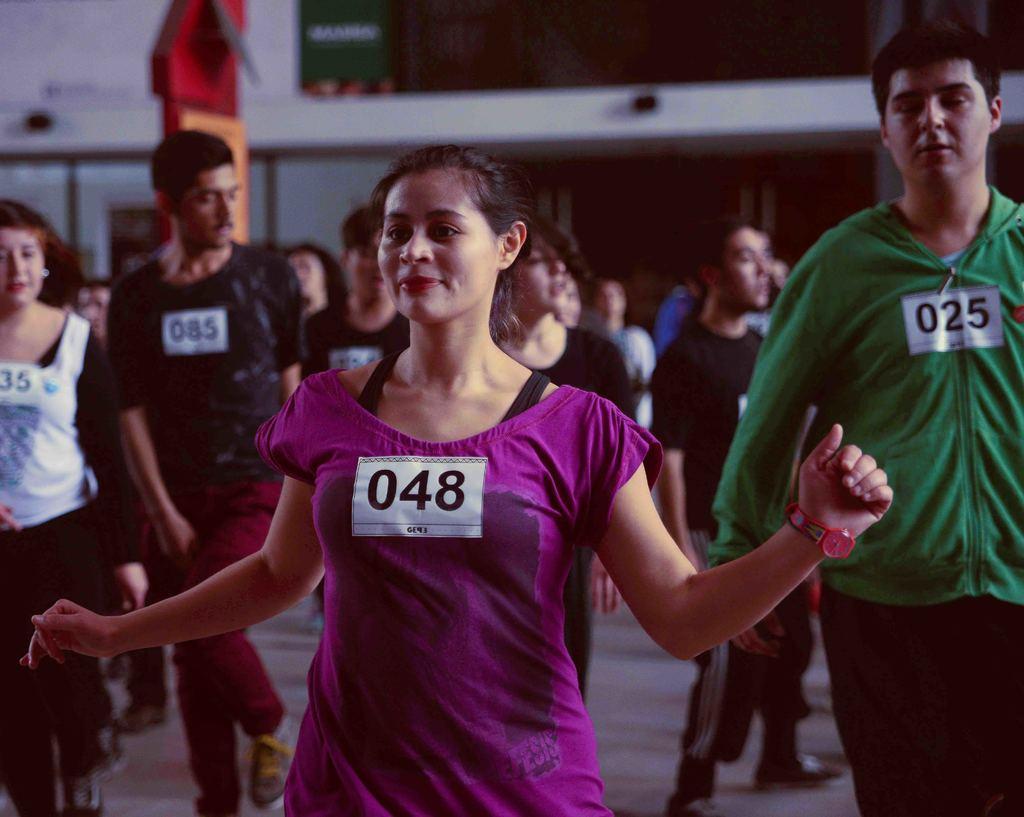How would you summarize this image in a sentence or two? In this picture we can observe some people. There are men and women in this picture. We can observe a woman wearing violet color t-shirt. On the right side there is a man standing. 